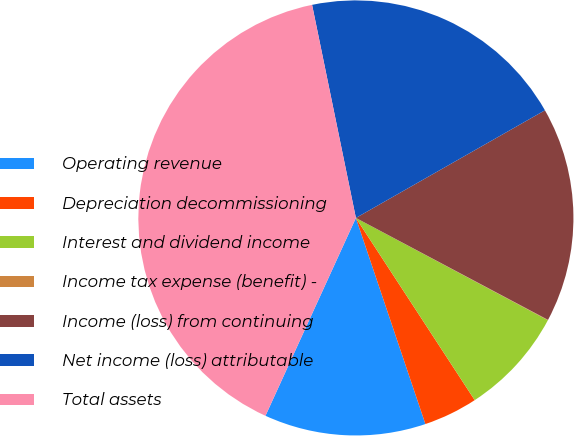Convert chart. <chart><loc_0><loc_0><loc_500><loc_500><pie_chart><fcel>Operating revenue<fcel>Depreciation decommissioning<fcel>Interest and dividend income<fcel>Income tax expense (benefit) -<fcel>Income (loss) from continuing<fcel>Net income (loss) attributable<fcel>Total assets<nl><fcel>12.0%<fcel>4.02%<fcel>8.01%<fcel>0.03%<fcel>16.0%<fcel>19.99%<fcel>39.95%<nl></chart> 